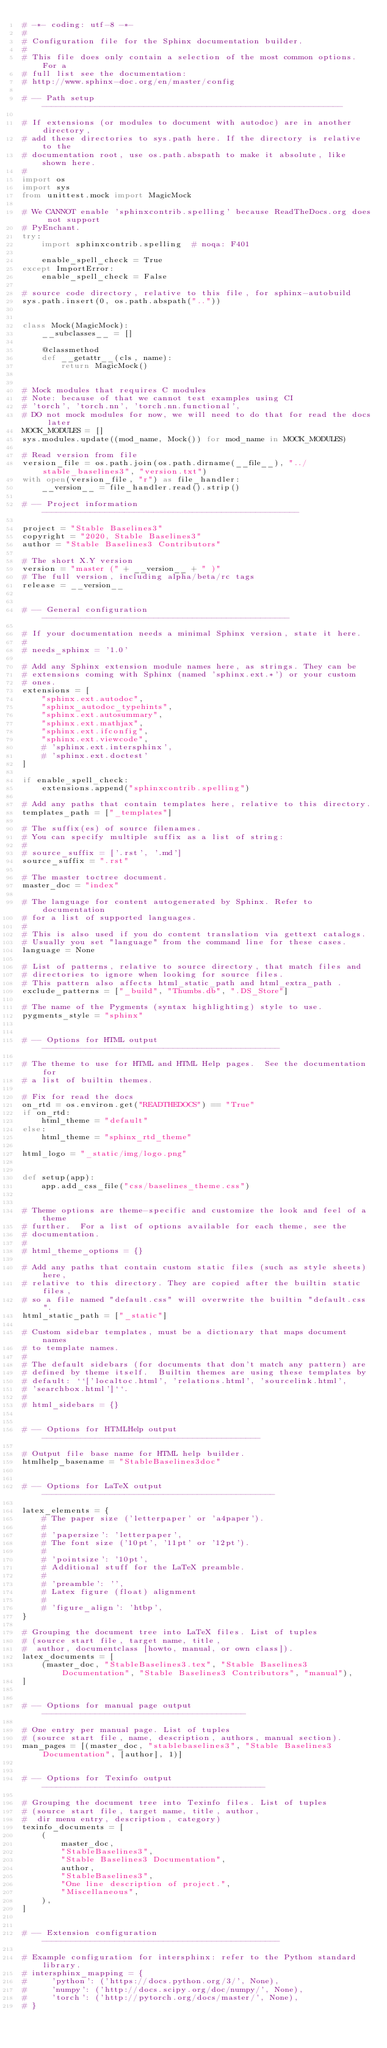Convert code to text. <code><loc_0><loc_0><loc_500><loc_500><_Python_># -*- coding: utf-8 -*-
#
# Configuration file for the Sphinx documentation builder.
#
# This file does only contain a selection of the most common options. For a
# full list see the documentation:
# http://www.sphinx-doc.org/en/master/config

# -- Path setup --------------------------------------------------------------

# If extensions (or modules to document with autodoc) are in another directory,
# add these directories to sys.path here. If the directory is relative to the
# documentation root, use os.path.abspath to make it absolute, like shown here.
#
import os
import sys
from unittest.mock import MagicMock

# We CANNOT enable 'sphinxcontrib.spelling' because ReadTheDocs.org does not support
# PyEnchant.
try:
    import sphinxcontrib.spelling  # noqa: F401

    enable_spell_check = True
except ImportError:
    enable_spell_check = False

# source code directory, relative to this file, for sphinx-autobuild
sys.path.insert(0, os.path.abspath(".."))


class Mock(MagicMock):
    __subclasses__ = []

    @classmethod
    def __getattr__(cls, name):
        return MagicMock()


# Mock modules that requires C modules
# Note: because of that we cannot test examples using CI
# 'torch', 'torch.nn', 'torch.nn.functional',
# DO not mock modules for now, we will need to do that for read the docs later
MOCK_MODULES = []
sys.modules.update((mod_name, Mock()) for mod_name in MOCK_MODULES)

# Read version from file
version_file = os.path.join(os.path.dirname(__file__), "../stable_baselines3", "version.txt")
with open(version_file, "r") as file_handler:
    __version__ = file_handler.read().strip()

# -- Project information -----------------------------------------------------

project = "Stable Baselines3"
copyright = "2020, Stable Baselines3"
author = "Stable Baselines3 Contributors"

# The short X.Y version
version = "master (" + __version__ + " )"
# The full version, including alpha/beta/rc tags
release = __version__


# -- General configuration ---------------------------------------------------

# If your documentation needs a minimal Sphinx version, state it here.
#
# needs_sphinx = '1.0'

# Add any Sphinx extension module names here, as strings. They can be
# extensions coming with Sphinx (named 'sphinx.ext.*') or your custom
# ones.
extensions = [
    "sphinx.ext.autodoc",
    "sphinx_autodoc_typehints",
    "sphinx.ext.autosummary",
    "sphinx.ext.mathjax",
    "sphinx.ext.ifconfig",
    "sphinx.ext.viewcode",
    # 'sphinx.ext.intersphinx',
    # 'sphinx.ext.doctest'
]

if enable_spell_check:
    extensions.append("sphinxcontrib.spelling")

# Add any paths that contain templates here, relative to this directory.
templates_path = ["_templates"]

# The suffix(es) of source filenames.
# You can specify multiple suffix as a list of string:
#
# source_suffix = ['.rst', '.md']
source_suffix = ".rst"

# The master toctree document.
master_doc = "index"

# The language for content autogenerated by Sphinx. Refer to documentation
# for a list of supported languages.
#
# This is also used if you do content translation via gettext catalogs.
# Usually you set "language" from the command line for these cases.
language = None

# List of patterns, relative to source directory, that match files and
# directories to ignore when looking for source files.
# This pattern also affects html_static_path and html_extra_path .
exclude_patterns = ["_build", "Thumbs.db", ".DS_Store"]

# The name of the Pygments (syntax highlighting) style to use.
pygments_style = "sphinx"


# -- Options for HTML output -------------------------------------------------

# The theme to use for HTML and HTML Help pages.  See the documentation for
# a list of builtin themes.

# Fix for read the docs
on_rtd = os.environ.get("READTHEDOCS") == "True"
if on_rtd:
    html_theme = "default"
else:
    html_theme = "sphinx_rtd_theme"

html_logo = "_static/img/logo.png"


def setup(app):
    app.add_css_file("css/baselines_theme.css")


# Theme options are theme-specific and customize the look and feel of a theme
# further.  For a list of options available for each theme, see the
# documentation.
#
# html_theme_options = {}

# Add any paths that contain custom static files (such as style sheets) here,
# relative to this directory. They are copied after the builtin static files,
# so a file named "default.css" will overwrite the builtin "default.css".
html_static_path = ["_static"]

# Custom sidebar templates, must be a dictionary that maps document names
# to template names.
#
# The default sidebars (for documents that don't match any pattern) are
# defined by theme itself.  Builtin themes are using these templates by
# default: ``['localtoc.html', 'relations.html', 'sourcelink.html',
# 'searchbox.html']``.
#
# html_sidebars = {}


# -- Options for HTMLHelp output ---------------------------------------------

# Output file base name for HTML help builder.
htmlhelp_basename = "StableBaselines3doc"


# -- Options for LaTeX output ------------------------------------------------

latex_elements = {
    # The paper size ('letterpaper' or 'a4paper').
    #
    # 'papersize': 'letterpaper',
    # The font size ('10pt', '11pt' or '12pt').
    #
    # 'pointsize': '10pt',
    # Additional stuff for the LaTeX preamble.
    #
    # 'preamble': '',
    # Latex figure (float) alignment
    #
    # 'figure_align': 'htbp',
}

# Grouping the document tree into LaTeX files. List of tuples
# (source start file, target name, title,
#  author, documentclass [howto, manual, or own class]).
latex_documents = [
    (master_doc, "StableBaselines3.tex", "Stable Baselines3 Documentation", "Stable Baselines3 Contributors", "manual"),
]


# -- Options for manual page output ------------------------------------------

# One entry per manual page. List of tuples
# (source start file, name, description, authors, manual section).
man_pages = [(master_doc, "stablebaselines3", "Stable Baselines3 Documentation", [author], 1)]


# -- Options for Texinfo output ----------------------------------------------

# Grouping the document tree into Texinfo files. List of tuples
# (source start file, target name, title, author,
#  dir menu entry, description, category)
texinfo_documents = [
    (
        master_doc,
        "StableBaselines3",
        "Stable Baselines3 Documentation",
        author,
        "StableBaselines3",
        "One line description of project.",
        "Miscellaneous",
    ),
]


# -- Extension configuration -------------------------------------------------

# Example configuration for intersphinx: refer to the Python standard library.
# intersphinx_mapping = {
#     'python': ('https://docs.python.org/3/', None),
#     'numpy': ('http://docs.scipy.org/doc/numpy/', None),
#     'torch': ('http://pytorch.org/docs/master/', None),
# }
</code> 